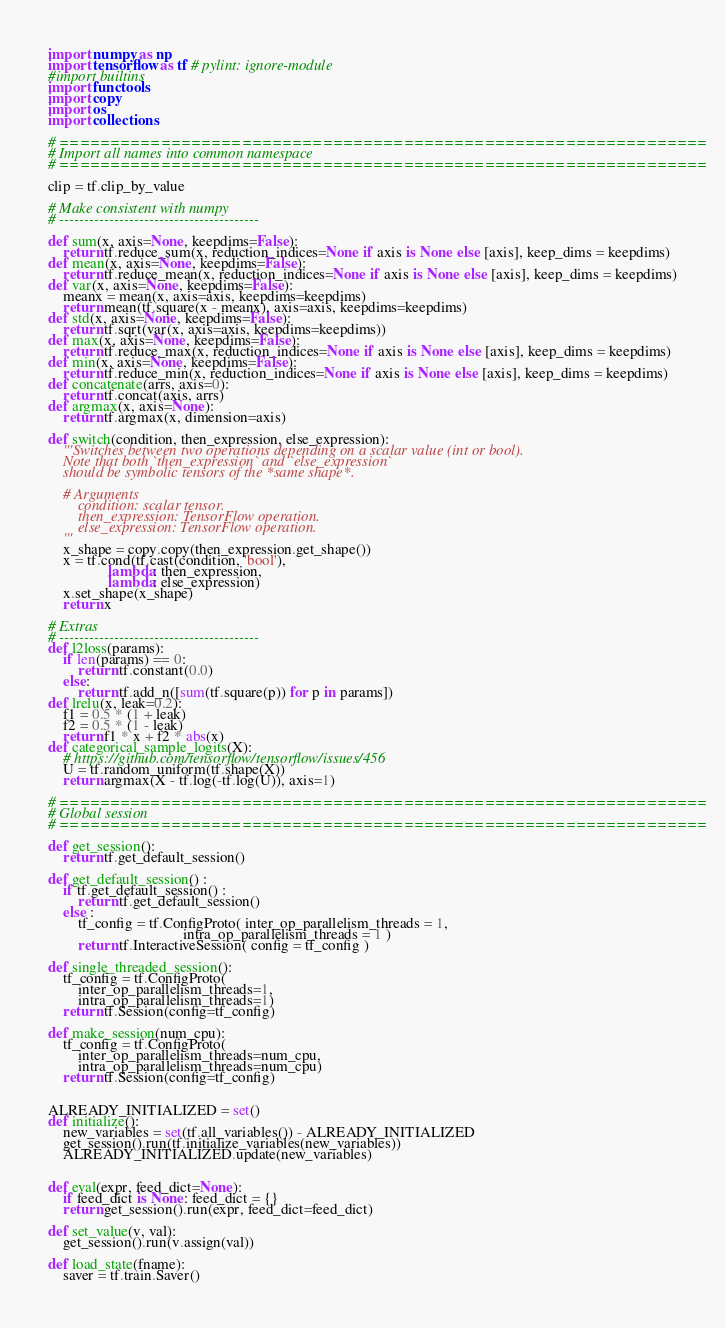Convert code to text. <code><loc_0><loc_0><loc_500><loc_500><_Python_>import numpy as np
import tensorflow as tf # pylint: ignore-module
#import builtins
import functools
import copy
import os
import collections

# ================================================================
# Import all names into common namespace
# ================================================================

clip = tf.clip_by_value

# Make consistent with numpy
# ----------------------------------------

def sum(x, axis=None, keepdims=False):
    return tf.reduce_sum(x, reduction_indices=None if axis is None else [axis], keep_dims = keepdims)
def mean(x, axis=None, keepdims=False):
    return tf.reduce_mean(x, reduction_indices=None if axis is None else [axis], keep_dims = keepdims)
def var(x, axis=None, keepdims=False):
    meanx = mean(x, axis=axis, keepdims=keepdims)
    return mean(tf.square(x - meanx), axis=axis, keepdims=keepdims)
def std(x, axis=None, keepdims=False):
    return tf.sqrt(var(x, axis=axis, keepdims=keepdims))
def max(x, axis=None, keepdims=False):
    return tf.reduce_max(x, reduction_indices=None if axis is None else [axis], keep_dims = keepdims)
def min(x, axis=None, keepdims=False):
    return tf.reduce_min(x, reduction_indices=None if axis is None else [axis], keep_dims = keepdims)
def concatenate(arrs, axis=0):
    return tf.concat(axis, arrs)
def argmax(x, axis=None):
    return tf.argmax(x, dimension=axis)

def switch(condition, then_expression, else_expression):
    '''Switches between two operations depending on a scalar value (int or bool).
    Note that both `then_expression` and `else_expression`
    should be symbolic tensors of the *same shape*.

    # Arguments
        condition: scalar tensor.
        then_expression: TensorFlow operation.
        else_expression: TensorFlow operation.
    '''
    x_shape = copy.copy(then_expression.get_shape())
    x = tf.cond(tf.cast(condition, 'bool'),
                lambda: then_expression,
                lambda: else_expression)
    x.set_shape(x_shape)
    return x

# Extras
# ----------------------------------------
def l2loss(params):
    if len(params) == 0:
        return tf.constant(0.0)
    else:
        return tf.add_n([sum(tf.square(p)) for p in params])
def lrelu(x, leak=0.2):
    f1 = 0.5 * (1 + leak)
    f2 = 0.5 * (1 - leak)
    return f1 * x + f2 * abs(x)
def categorical_sample_logits(X):
    # https://github.com/tensorflow/tensorflow/issues/456
    U = tf.random_uniform(tf.shape(X))
    return argmax(X - tf.log(-tf.log(U)), axis=1)

# ================================================================
# Global session
# ================================================================

def get_session():
    return tf.get_default_session()

def get_default_session() :
    if tf.get_default_session() :
        return tf.get_default_session()
    else :
        tf_config = tf.ConfigProto( inter_op_parallelism_threads = 1,
                                    intra_op_parallelism_threads = 1 )
        return tf.InteractiveSession( config = tf_config )

def single_threaded_session():
    tf_config = tf.ConfigProto(
        inter_op_parallelism_threads=1,
        intra_op_parallelism_threads=1)
    return tf.Session(config=tf_config)

def make_session(num_cpu):
    tf_config = tf.ConfigProto(
        inter_op_parallelism_threads=num_cpu,
        intra_op_parallelism_threads=num_cpu)
    return tf.Session(config=tf_config)


ALREADY_INITIALIZED = set()
def initialize():
    new_variables = set(tf.all_variables()) - ALREADY_INITIALIZED
    get_session().run(tf.initialize_variables(new_variables))
    ALREADY_INITIALIZED.update(new_variables)


def eval(expr, feed_dict=None):
    if feed_dict is None: feed_dict = {}
    return get_session().run(expr, feed_dict=feed_dict)

def set_value(v, val):
    get_session().run(v.assign(val))

def load_state(fname):
    saver = tf.train.Saver()</code> 